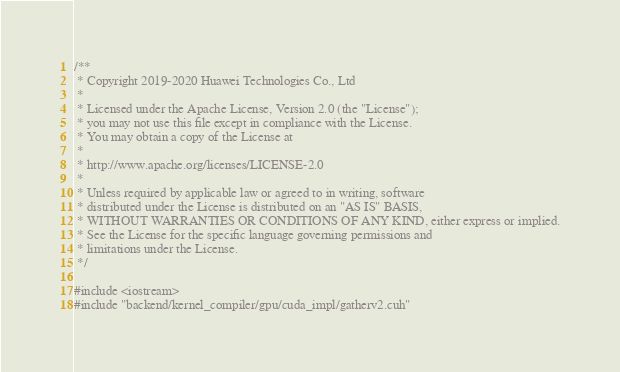<code> <loc_0><loc_0><loc_500><loc_500><_Cuda_>/**
 * Copyright 2019-2020 Huawei Technologies Co., Ltd
 *
 * Licensed under the Apache License, Version 2.0 (the "License");
 * you may not use this file except in compliance with the License.
 * You may obtain a copy of the License at
 *
 * http://www.apache.org/licenses/LICENSE-2.0
 *
 * Unless required by applicable law or agreed to in writing, software
 * distributed under the License is distributed on an "AS IS" BASIS,
 * WITHOUT WARRANTIES OR CONDITIONS OF ANY KIND, either express or implied.
 * See the License for the specific language governing permissions and
 * limitations under the License.
 */

#include <iostream>
#include "backend/kernel_compiler/gpu/cuda_impl/gatherv2.cuh"</code> 